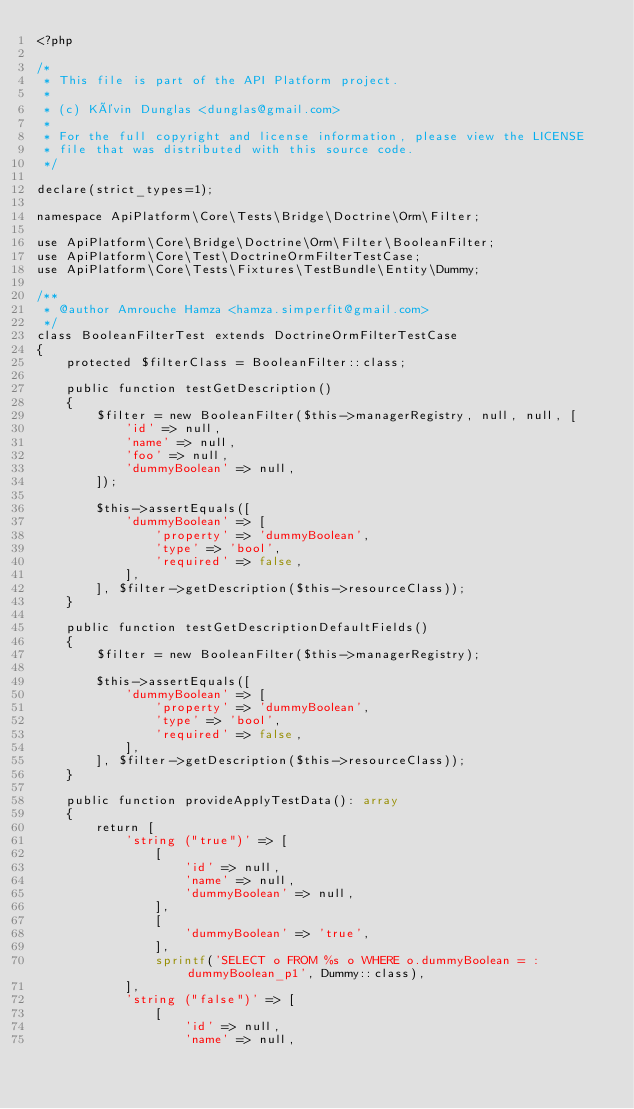Convert code to text. <code><loc_0><loc_0><loc_500><loc_500><_PHP_><?php

/*
 * This file is part of the API Platform project.
 *
 * (c) Kévin Dunglas <dunglas@gmail.com>
 *
 * For the full copyright and license information, please view the LICENSE
 * file that was distributed with this source code.
 */

declare(strict_types=1);

namespace ApiPlatform\Core\Tests\Bridge\Doctrine\Orm\Filter;

use ApiPlatform\Core\Bridge\Doctrine\Orm\Filter\BooleanFilter;
use ApiPlatform\Core\Test\DoctrineOrmFilterTestCase;
use ApiPlatform\Core\Tests\Fixtures\TestBundle\Entity\Dummy;

/**
 * @author Amrouche Hamza <hamza.simperfit@gmail.com>
 */
class BooleanFilterTest extends DoctrineOrmFilterTestCase
{
    protected $filterClass = BooleanFilter::class;

    public function testGetDescription()
    {
        $filter = new BooleanFilter($this->managerRegistry, null, null, [
            'id' => null,
            'name' => null,
            'foo' => null,
            'dummyBoolean' => null,
        ]);

        $this->assertEquals([
            'dummyBoolean' => [
                'property' => 'dummyBoolean',
                'type' => 'bool',
                'required' => false,
            ],
        ], $filter->getDescription($this->resourceClass));
    }

    public function testGetDescriptionDefaultFields()
    {
        $filter = new BooleanFilter($this->managerRegistry);

        $this->assertEquals([
            'dummyBoolean' => [
                'property' => 'dummyBoolean',
                'type' => 'bool',
                'required' => false,
            ],
        ], $filter->getDescription($this->resourceClass));
    }

    public function provideApplyTestData(): array
    {
        return [
            'string ("true")' => [
                [
                    'id' => null,
                    'name' => null,
                    'dummyBoolean' => null,
                ],
                [
                    'dummyBoolean' => 'true',
                ],
                sprintf('SELECT o FROM %s o WHERE o.dummyBoolean = :dummyBoolean_p1', Dummy::class),
            ],
            'string ("false")' => [
                [
                    'id' => null,
                    'name' => null,</code> 